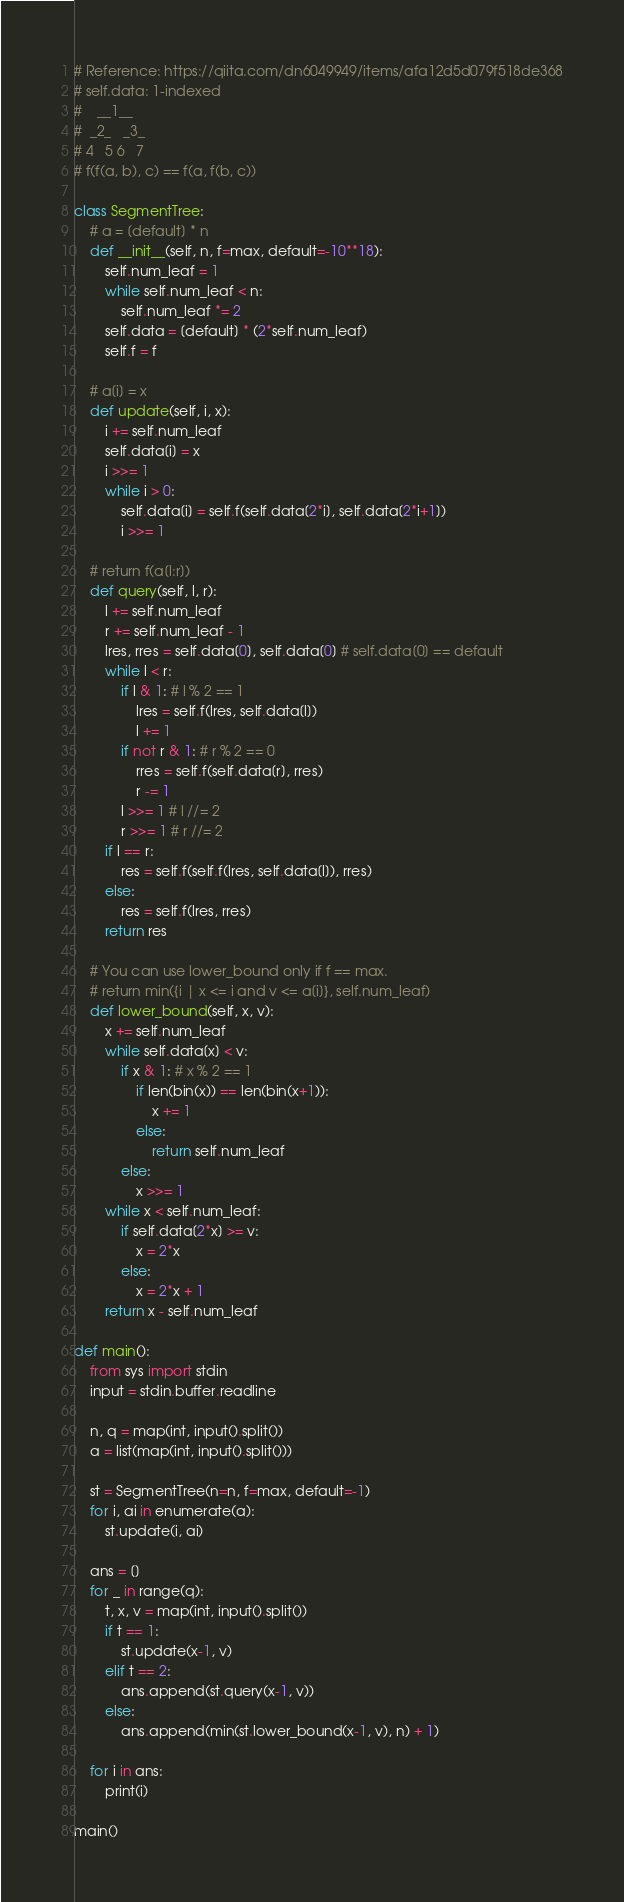Convert code to text. <code><loc_0><loc_0><loc_500><loc_500><_Python_># Reference: https://qiita.com/dn6049949/items/afa12d5d079f518de368
# self.data: 1-indexed
#    __1__
#  _2_   _3_
# 4   5 6   7
# f(f(a, b), c) == f(a, f(b, c))

class SegmentTree:
    # a = [default] * n
    def __init__(self, n, f=max, default=-10**18):
        self.num_leaf = 1
        while self.num_leaf < n:
            self.num_leaf *= 2
        self.data = [default] * (2*self.num_leaf)
        self.f = f

    # a[i] = x
    def update(self, i, x):
        i += self.num_leaf
        self.data[i] = x
        i >>= 1
        while i > 0:
            self.data[i] = self.f(self.data[2*i], self.data[2*i+1])
            i >>= 1

    # return f(a[l:r])
    def query(self, l, r):
        l += self.num_leaf
        r += self.num_leaf - 1
        lres, rres = self.data[0], self.data[0] # self.data[0] == default
        while l < r:
            if l & 1: # l % 2 == 1
                lres = self.f(lres, self.data[l])
                l += 1
            if not r & 1: # r % 2 == 0
                rres = self.f(self.data[r], rres)
                r -= 1
            l >>= 1 # l //= 2
            r >>= 1 # r //= 2
        if l == r:
            res = self.f(self.f(lres, self.data[l]), rres)
        else:
            res = self.f(lres, rres)
        return res

    # You can use lower_bound only if f == max.
    # return min({i | x <= i and v <= a[i]}, self.num_leaf)
    def lower_bound(self, x, v):
        x += self.num_leaf
        while self.data[x] < v:
            if x & 1: # x % 2 == 1
                if len(bin(x)) == len(bin(x+1)):
                    x += 1
                else:
                    return self.num_leaf
            else:
                x >>= 1
        while x < self.num_leaf:
            if self.data[2*x] >= v:
                x = 2*x
            else:
                x = 2*x + 1
        return x - self.num_leaf

def main():
    from sys import stdin
    input = stdin.buffer.readline

    n, q = map(int, input().split())
    a = list(map(int, input().split()))

    st = SegmentTree(n=n, f=max, default=-1)
    for i, ai in enumerate(a):
        st.update(i, ai)

    ans = []
    for _ in range(q):
        t, x, v = map(int, input().split())
        if t == 1:
            st.update(x-1, v)
        elif t == 2:
            ans.append(st.query(x-1, v))
        else:
            ans.append(min(st.lower_bound(x-1, v), n) + 1)
    
    for i in ans:
        print(i)

main()</code> 